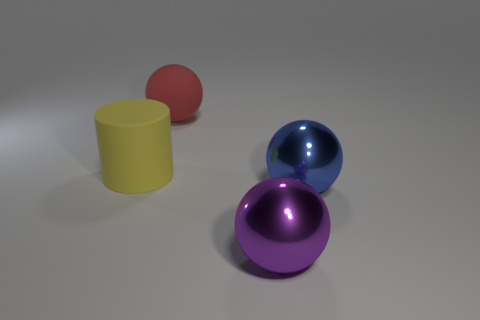What material is the big purple object that is the same shape as the large blue thing?
Provide a short and direct response. Metal. There is a ball on the right side of the large metal ball in front of the big blue metal thing; what is its size?
Provide a short and direct response. Large. There is a big ball that is on the right side of the large purple thing; what material is it?
Offer a very short reply. Metal. The sphere that is the same material as the purple thing is what size?
Your answer should be very brief. Large. How many large blue objects have the same shape as the big red rubber object?
Ensure brevity in your answer.  1. There is a purple thing; does it have the same shape as the large thing that is to the left of the red matte ball?
Your answer should be very brief. No. Is there a large purple object that has the same material as the large yellow cylinder?
Keep it short and to the point. No. Is there any other thing that has the same material as the large cylinder?
Offer a very short reply. Yes. There is a sphere that is behind the yellow object that is left of the purple metal thing; what is it made of?
Keep it short and to the point. Rubber. There is a shiny sphere that is in front of the blue ball that is on the right side of the object that is behind the matte cylinder; what size is it?
Ensure brevity in your answer.  Large. 